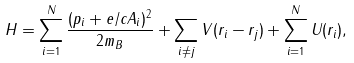Convert formula to latex. <formula><loc_0><loc_0><loc_500><loc_500>H = \sum _ { i = 1 } ^ { N } \frac { ( { p } _ { i } + e / c { A } _ { i } ) ^ { 2 } } { 2 m _ { B } } + \sum _ { i \neq j } V ( { r } _ { i } - { r } _ { j } ) + \sum _ { i = 1 } ^ { N } U ( { r } _ { i } ) ,</formula> 